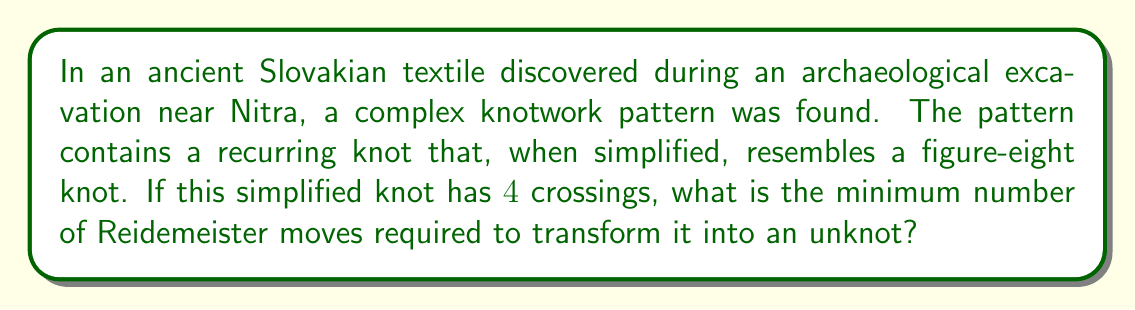Solve this math problem. Let's approach this step-by-step:

1) First, recall that the figure-eight knot is the simplest non-trivial knot, with a crossing number of 4.

2) The Reidemeister moves are a set of three local moves on a knot diagram that can be used to change the diagram without changing the underlying knot type. These moves are:
   - Type I: Twist or untwist a strand
   - Type II: Move one strand completely over or under another
   - Type III: Move a strand over or under a crossing

3) To unknot a figure-eight knot, we need to use a combination of these moves. The minimum number of moves required is known to be 4.

4) The sequence of moves to unknot a figure-eight knot is as follows:
   - Apply a Type II move to create two adjacent crossings
   - Apply a Type III move to slide one crossing past another
   - Apply another Type II move to remove two crossings
   - Finally, apply a Type I move to remove the last twist

5) Each of these moves reduces the complexity of the knot until we reach the unknot.

Therefore, the minimum number of Reidemeister moves required to transform the simplified knot from the ancient Slovakian textile into an unknot is 4.
Answer: 4 